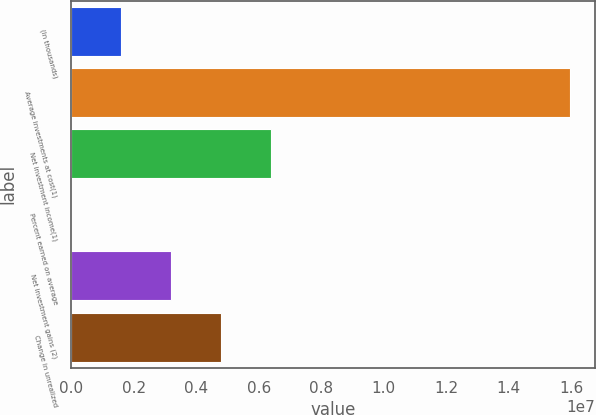Convert chart to OTSL. <chart><loc_0><loc_0><loc_500><loc_500><bar_chart><fcel>(In thousands)<fcel>Average investments at cost(1)<fcel>Net investment income(1)<fcel>Percent earned on average<fcel>Net investment gains (2)<fcel>Change in unrealized<nl><fcel>1.5971e+06<fcel>1.59709e+07<fcel>6.38837e+06<fcel>3.2<fcel>3.19419e+06<fcel>4.79128e+06<nl></chart> 